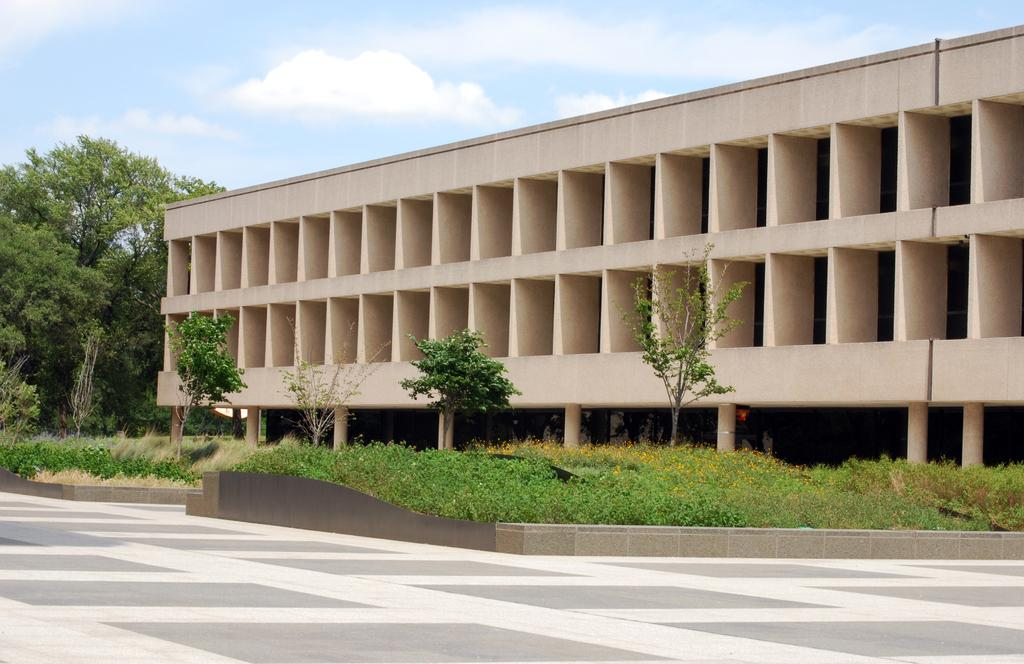What type of vegetation is in the middle of the image? There are plants and trees in the middle of the image. What structure is located behind the trees? There is a building behind the trees. What can be seen in the sky at the top of the image? Clouds and the sky are visible at the top of the image. What organization has approved the play in the image? There is no play or organization present in the image; it features plants, trees, a building, clouds, and the sky. 